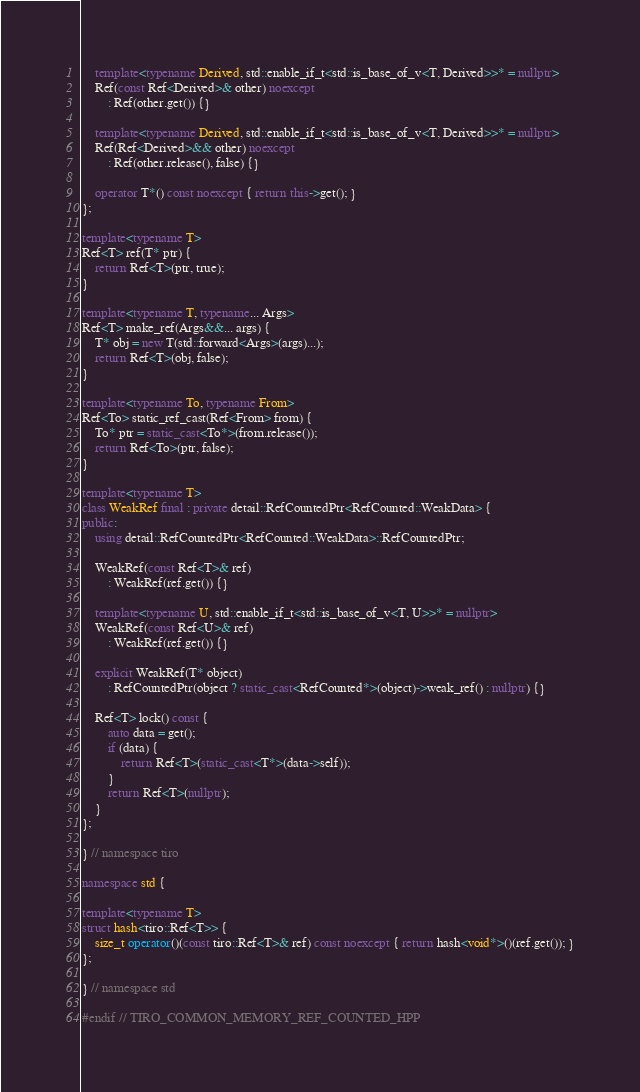Convert code to text. <code><loc_0><loc_0><loc_500><loc_500><_C++_>    template<typename Derived, std::enable_if_t<std::is_base_of_v<T, Derived>>* = nullptr>
    Ref(const Ref<Derived>& other) noexcept
        : Ref(other.get()) {}

    template<typename Derived, std::enable_if_t<std::is_base_of_v<T, Derived>>* = nullptr>
    Ref(Ref<Derived>&& other) noexcept
        : Ref(other.release(), false) {}

    operator T*() const noexcept { return this->get(); }
};

template<typename T>
Ref<T> ref(T* ptr) {
    return Ref<T>(ptr, true);
}

template<typename T, typename... Args>
Ref<T> make_ref(Args&&... args) {
    T* obj = new T(std::forward<Args>(args)...);
    return Ref<T>(obj, false);
}

template<typename To, typename From>
Ref<To> static_ref_cast(Ref<From> from) {
    To* ptr = static_cast<To*>(from.release());
    return Ref<To>(ptr, false);
}

template<typename T>
class WeakRef final : private detail::RefCountedPtr<RefCounted::WeakData> {
public:
    using detail::RefCountedPtr<RefCounted::WeakData>::RefCountedPtr;

    WeakRef(const Ref<T>& ref)
        : WeakRef(ref.get()) {}

    template<typename U, std::enable_if_t<std::is_base_of_v<T, U>>* = nullptr>
    WeakRef(const Ref<U>& ref)
        : WeakRef(ref.get()) {}

    explicit WeakRef(T* object)
        : RefCountedPtr(object ? static_cast<RefCounted*>(object)->weak_ref() : nullptr) {}

    Ref<T> lock() const {
        auto data = get();
        if (data) {
            return Ref<T>(static_cast<T*>(data->self));
        }
        return Ref<T>(nullptr);
    }
};

} // namespace tiro

namespace std {

template<typename T>
struct hash<tiro::Ref<T>> {
    size_t operator()(const tiro::Ref<T>& ref) const noexcept { return hash<void*>()(ref.get()); }
};

} // namespace std

#endif // TIRO_COMMON_MEMORY_REF_COUNTED_HPP
</code> 